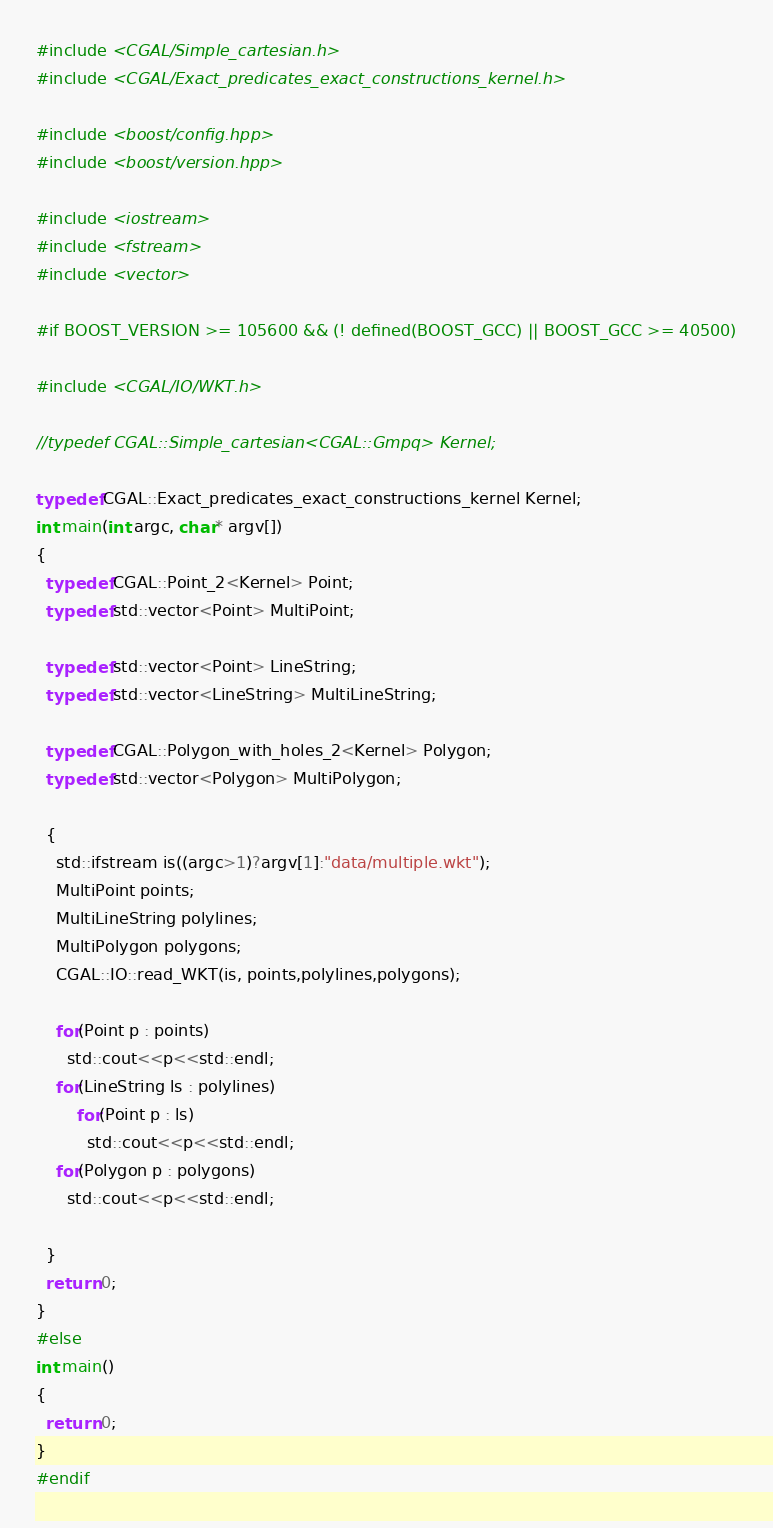Convert code to text. <code><loc_0><loc_0><loc_500><loc_500><_C++_>#include <CGAL/Simple_cartesian.h>
#include <CGAL/Exact_predicates_exact_constructions_kernel.h>

#include <boost/config.hpp>
#include <boost/version.hpp>

#include <iostream>
#include <fstream>
#include <vector>

#if BOOST_VERSION >= 105600 && (! defined(BOOST_GCC) || BOOST_GCC >= 40500)

#include <CGAL/IO/WKT.h>

//typedef CGAL::Simple_cartesian<CGAL::Gmpq> Kernel;

typedef CGAL::Exact_predicates_exact_constructions_kernel Kernel;
int main(int argc, char* argv[])
{
  typedef CGAL::Point_2<Kernel> Point;
  typedef std::vector<Point> MultiPoint;

  typedef std::vector<Point> LineString;
  typedef std::vector<LineString> MultiLineString;

  typedef CGAL::Polygon_with_holes_2<Kernel> Polygon;
  typedef std::vector<Polygon> MultiPolygon;

  {
    std::ifstream is((argc>1)?argv[1]:"data/multiple.wkt");
    MultiPoint points;
    MultiLineString polylines;
    MultiPolygon polygons;
    CGAL::IO::read_WKT(is, points,polylines,polygons);

    for(Point p : points)
      std::cout<<p<<std::endl;
    for(LineString ls : polylines)
        for(Point p : ls)
          std::cout<<p<<std::endl;
    for(Polygon p : polygons)
      std::cout<<p<<std::endl;

  }
  return 0;
}
#else
int main()
{
  return 0;
}
#endif
</code> 